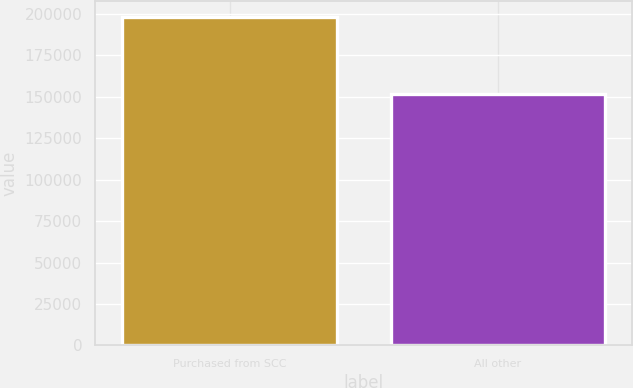Convert chart. <chart><loc_0><loc_0><loc_500><loc_500><bar_chart><fcel>Purchased from SCC<fcel>All other<nl><fcel>198204<fcel>152031<nl></chart> 